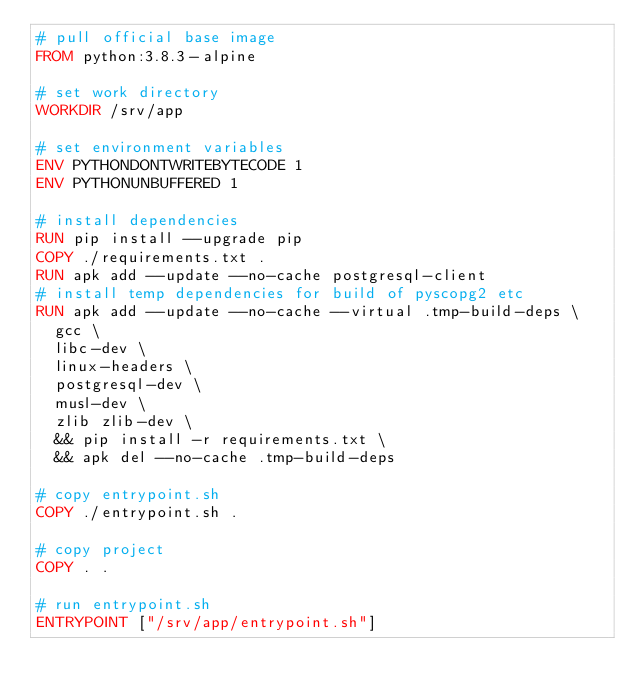<code> <loc_0><loc_0><loc_500><loc_500><_Dockerfile_># pull official base image
FROM python:3.8.3-alpine

# set work directory
WORKDIR /srv/app

# set environment variables
ENV PYTHONDONTWRITEBYTECODE 1
ENV PYTHONUNBUFFERED 1

# install dependencies
RUN pip install --upgrade pip
COPY ./requirements.txt .
RUN apk add --update --no-cache postgresql-client
# install temp dependencies for build of pyscopg2 etc
RUN apk add --update --no-cache --virtual .tmp-build-deps \
  gcc \
  libc-dev \
  linux-headers \
  postgresql-dev \
  musl-dev \
  zlib zlib-dev \
  && pip install -r requirements.txt \
  && apk del --no-cache .tmp-build-deps

# copy entrypoint.sh
COPY ./entrypoint.sh .

# copy project
COPY . .

# run entrypoint.sh
ENTRYPOINT ["/srv/app/entrypoint.sh"]</code> 